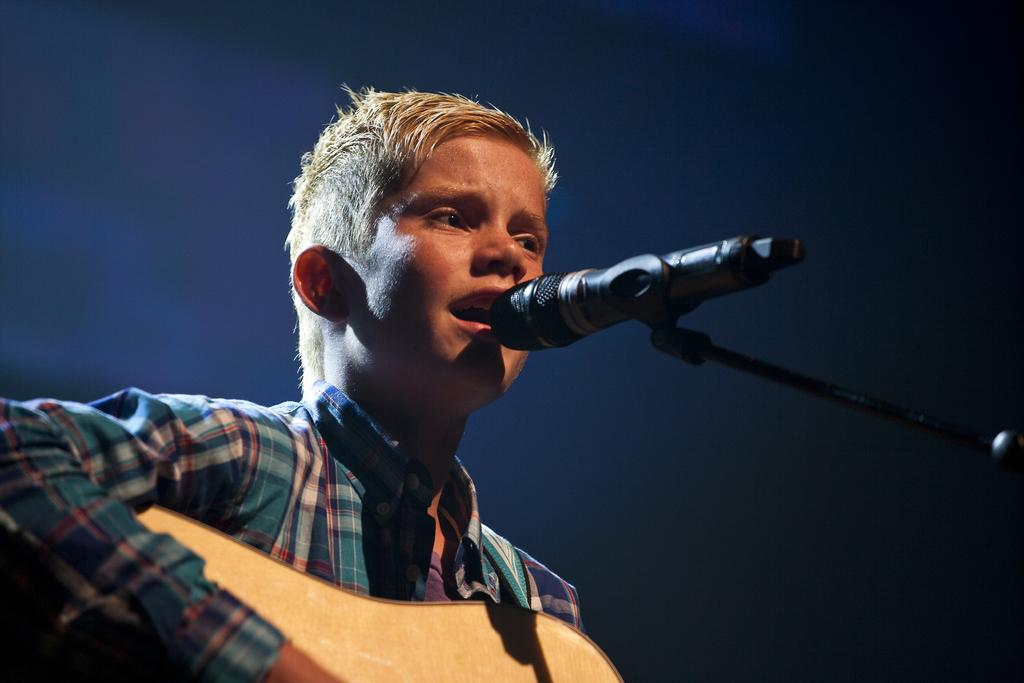What is the main subject of the image? There is a person in the image. What is the person doing in the image? The person is singing a song and playing a guitar. What object is the person holding in the image? The person is holding a microphone. What type of frogs can be seen playing the guitar in the image? There are no frogs present in the image, and therefore no such activity can be observed. What creature is shown interacting with the person in the image? There is no creature shown interacting with the person in the image; only the person, the guitar, and the microphone are present. 